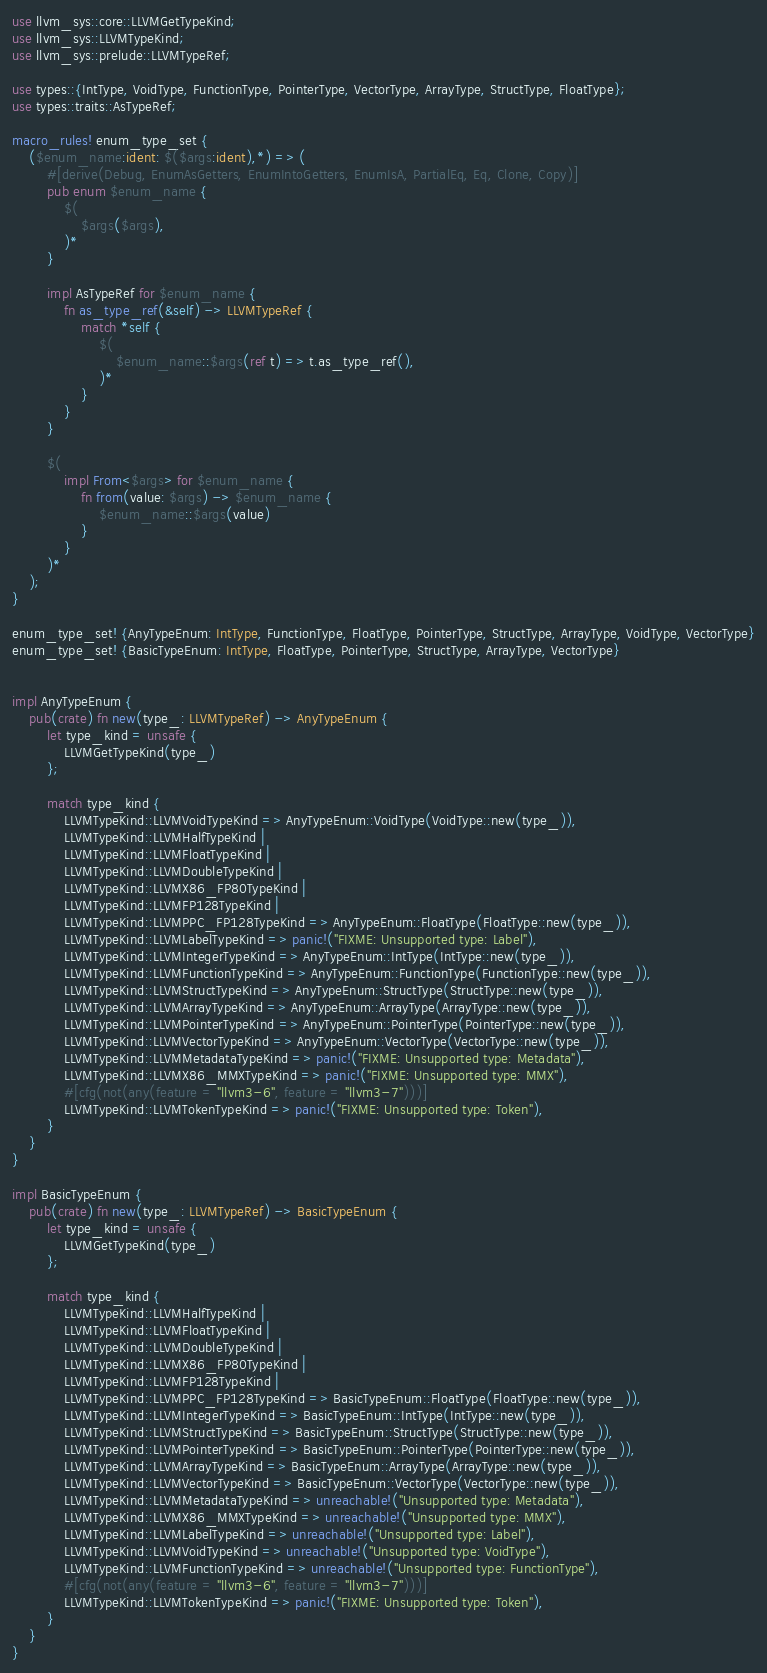Convert code to text. <code><loc_0><loc_0><loc_500><loc_500><_Rust_>use llvm_sys::core::LLVMGetTypeKind;
use llvm_sys::LLVMTypeKind;
use llvm_sys::prelude::LLVMTypeRef;

use types::{IntType, VoidType, FunctionType, PointerType, VectorType, ArrayType, StructType, FloatType};
use types::traits::AsTypeRef;

macro_rules! enum_type_set {
    ($enum_name:ident: $($args:ident),*) => (
        #[derive(Debug, EnumAsGetters, EnumIntoGetters, EnumIsA, PartialEq, Eq, Clone, Copy)]
        pub enum $enum_name {
            $(
                $args($args),
            )*
        }

        impl AsTypeRef for $enum_name {
            fn as_type_ref(&self) -> LLVMTypeRef {
                match *self {
                    $(
                        $enum_name::$args(ref t) => t.as_type_ref(),
                    )*
                }
            }
        }

        $(
            impl From<$args> for $enum_name {
                fn from(value: $args) -> $enum_name {
                    $enum_name::$args(value)
                }
            }
        )*
    );
}

enum_type_set! {AnyTypeEnum: IntType, FunctionType, FloatType, PointerType, StructType, ArrayType, VoidType, VectorType}
enum_type_set! {BasicTypeEnum: IntType, FloatType, PointerType, StructType, ArrayType, VectorType}


impl AnyTypeEnum {
    pub(crate) fn new(type_: LLVMTypeRef) -> AnyTypeEnum {
        let type_kind = unsafe {
            LLVMGetTypeKind(type_)
        };

        match type_kind {
            LLVMTypeKind::LLVMVoidTypeKind => AnyTypeEnum::VoidType(VoidType::new(type_)),
            LLVMTypeKind::LLVMHalfTypeKind |
            LLVMTypeKind::LLVMFloatTypeKind |
            LLVMTypeKind::LLVMDoubleTypeKind |
            LLVMTypeKind::LLVMX86_FP80TypeKind |
            LLVMTypeKind::LLVMFP128TypeKind |
            LLVMTypeKind::LLVMPPC_FP128TypeKind => AnyTypeEnum::FloatType(FloatType::new(type_)),
            LLVMTypeKind::LLVMLabelTypeKind => panic!("FIXME: Unsupported type: Label"),
            LLVMTypeKind::LLVMIntegerTypeKind => AnyTypeEnum::IntType(IntType::new(type_)),
            LLVMTypeKind::LLVMFunctionTypeKind => AnyTypeEnum::FunctionType(FunctionType::new(type_)),
            LLVMTypeKind::LLVMStructTypeKind => AnyTypeEnum::StructType(StructType::new(type_)),
            LLVMTypeKind::LLVMArrayTypeKind => AnyTypeEnum::ArrayType(ArrayType::new(type_)),
            LLVMTypeKind::LLVMPointerTypeKind => AnyTypeEnum::PointerType(PointerType::new(type_)),
            LLVMTypeKind::LLVMVectorTypeKind => AnyTypeEnum::VectorType(VectorType::new(type_)),
            LLVMTypeKind::LLVMMetadataTypeKind => panic!("FIXME: Unsupported type: Metadata"),
            LLVMTypeKind::LLVMX86_MMXTypeKind => panic!("FIXME: Unsupported type: MMX"),
            #[cfg(not(any(feature = "llvm3-6", feature = "llvm3-7")))]
            LLVMTypeKind::LLVMTokenTypeKind => panic!("FIXME: Unsupported type: Token"),
        }
    }
}

impl BasicTypeEnum {
    pub(crate) fn new(type_: LLVMTypeRef) -> BasicTypeEnum {
        let type_kind = unsafe {
            LLVMGetTypeKind(type_)
        };

        match type_kind {
            LLVMTypeKind::LLVMHalfTypeKind |
            LLVMTypeKind::LLVMFloatTypeKind |
            LLVMTypeKind::LLVMDoubleTypeKind |
            LLVMTypeKind::LLVMX86_FP80TypeKind |
            LLVMTypeKind::LLVMFP128TypeKind |
            LLVMTypeKind::LLVMPPC_FP128TypeKind => BasicTypeEnum::FloatType(FloatType::new(type_)),
            LLVMTypeKind::LLVMIntegerTypeKind => BasicTypeEnum::IntType(IntType::new(type_)),
            LLVMTypeKind::LLVMStructTypeKind => BasicTypeEnum::StructType(StructType::new(type_)),
            LLVMTypeKind::LLVMPointerTypeKind => BasicTypeEnum::PointerType(PointerType::new(type_)),
            LLVMTypeKind::LLVMArrayTypeKind => BasicTypeEnum::ArrayType(ArrayType::new(type_)),
            LLVMTypeKind::LLVMVectorTypeKind => BasicTypeEnum::VectorType(VectorType::new(type_)),
            LLVMTypeKind::LLVMMetadataTypeKind => unreachable!("Unsupported type: Metadata"),
            LLVMTypeKind::LLVMX86_MMXTypeKind => unreachable!("Unsupported type: MMX"),
            LLVMTypeKind::LLVMLabelTypeKind => unreachable!("Unsupported type: Label"),
            LLVMTypeKind::LLVMVoidTypeKind => unreachable!("Unsupported type: VoidType"),
            LLVMTypeKind::LLVMFunctionTypeKind => unreachable!("Unsupported type: FunctionType"),
            #[cfg(not(any(feature = "llvm3-6", feature = "llvm3-7")))]
            LLVMTypeKind::LLVMTokenTypeKind => panic!("FIXME: Unsupported type: Token"),
        }
    }
}
</code> 